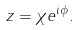Convert formula to latex. <formula><loc_0><loc_0><loc_500><loc_500>z = \chi e ^ { i \phi } .</formula> 